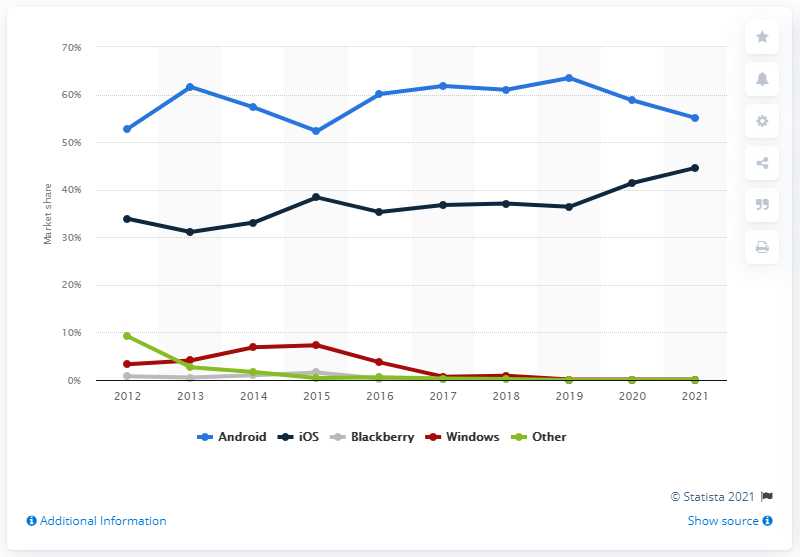What can be inferred about the market share of Blackberry over the years? The red line, representing Blackberry's market share, indicates a steady decline throughout the decade, dropping from around 10% in 2012 to nearly 0% by 2021. And what about Windows, how does the graph present its market share changes? Windows' market share, shown by the green line, experiences a decline in the earlier years, followed by a relatively flat line, suggesting a stabilization at a lower market share towards the latter part of the decade. 